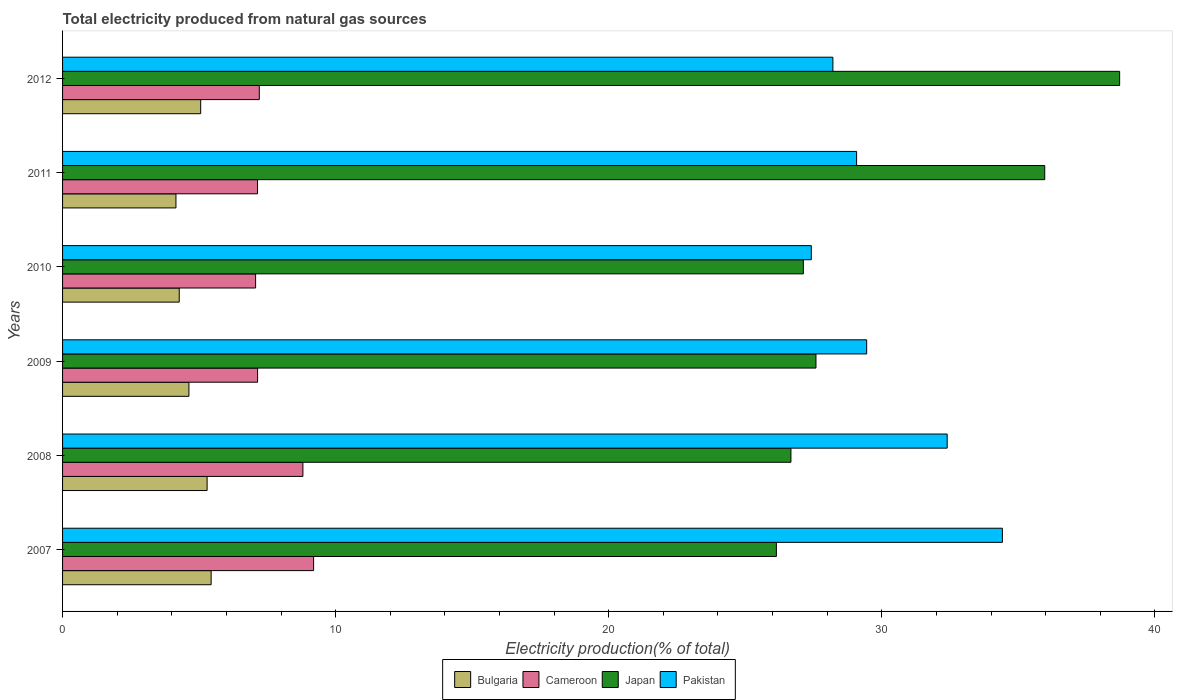How many groups of bars are there?
Your answer should be very brief. 6. Are the number of bars per tick equal to the number of legend labels?
Your response must be concise. Yes. Are the number of bars on each tick of the Y-axis equal?
Your response must be concise. Yes. How many bars are there on the 3rd tick from the top?
Give a very brief answer. 4. How many bars are there on the 4th tick from the bottom?
Your answer should be very brief. 4. What is the total electricity produced in Bulgaria in 2010?
Make the answer very short. 4.27. Across all years, what is the maximum total electricity produced in Japan?
Offer a terse response. 38.71. Across all years, what is the minimum total electricity produced in Japan?
Offer a very short reply. 26.14. What is the total total electricity produced in Japan in the graph?
Offer a very short reply. 182.21. What is the difference between the total electricity produced in Japan in 2007 and that in 2011?
Your response must be concise. -9.83. What is the difference between the total electricity produced in Japan in 2010 and the total electricity produced in Cameroon in 2007?
Your answer should be very brief. 17.93. What is the average total electricity produced in Bulgaria per year?
Ensure brevity in your answer.  4.81. In the year 2010, what is the difference between the total electricity produced in Cameroon and total electricity produced in Pakistan?
Your answer should be compact. -20.35. In how many years, is the total electricity produced in Japan greater than 14 %?
Offer a very short reply. 6. What is the ratio of the total electricity produced in Pakistan in 2011 to that in 2012?
Your response must be concise. 1.03. Is the total electricity produced in Cameroon in 2008 less than that in 2009?
Give a very brief answer. No. What is the difference between the highest and the second highest total electricity produced in Bulgaria?
Provide a succinct answer. 0.15. What is the difference between the highest and the lowest total electricity produced in Japan?
Keep it short and to the point. 12.57. What does the 3rd bar from the bottom in 2007 represents?
Give a very brief answer. Japan. Are the values on the major ticks of X-axis written in scientific E-notation?
Keep it short and to the point. No. Does the graph contain any zero values?
Give a very brief answer. No. Where does the legend appear in the graph?
Keep it short and to the point. Bottom center. How are the legend labels stacked?
Keep it short and to the point. Horizontal. What is the title of the graph?
Your response must be concise. Total electricity produced from natural gas sources. What is the label or title of the Y-axis?
Your answer should be compact. Years. What is the Electricity production(% of total) in Bulgaria in 2007?
Keep it short and to the point. 5.44. What is the Electricity production(% of total) in Cameroon in 2007?
Keep it short and to the point. 9.19. What is the Electricity production(% of total) of Japan in 2007?
Ensure brevity in your answer.  26.14. What is the Electricity production(% of total) of Pakistan in 2007?
Offer a terse response. 34.42. What is the Electricity production(% of total) in Bulgaria in 2008?
Make the answer very short. 5.29. What is the Electricity production(% of total) in Cameroon in 2008?
Keep it short and to the point. 8.8. What is the Electricity production(% of total) in Japan in 2008?
Offer a very short reply. 26.67. What is the Electricity production(% of total) in Pakistan in 2008?
Your response must be concise. 32.39. What is the Electricity production(% of total) of Bulgaria in 2009?
Your response must be concise. 4.63. What is the Electricity production(% of total) in Cameroon in 2009?
Provide a short and direct response. 7.14. What is the Electricity production(% of total) of Japan in 2009?
Keep it short and to the point. 27.59. What is the Electricity production(% of total) in Pakistan in 2009?
Offer a terse response. 29.45. What is the Electricity production(% of total) of Bulgaria in 2010?
Offer a very short reply. 4.27. What is the Electricity production(% of total) of Cameroon in 2010?
Ensure brevity in your answer.  7.07. What is the Electricity production(% of total) of Japan in 2010?
Provide a succinct answer. 27.13. What is the Electricity production(% of total) of Pakistan in 2010?
Make the answer very short. 27.42. What is the Electricity production(% of total) in Bulgaria in 2011?
Your answer should be compact. 4.15. What is the Electricity production(% of total) in Cameroon in 2011?
Provide a succinct answer. 7.14. What is the Electricity production(% of total) of Japan in 2011?
Provide a succinct answer. 35.97. What is the Electricity production(% of total) of Pakistan in 2011?
Make the answer very short. 29.08. What is the Electricity production(% of total) of Bulgaria in 2012?
Your answer should be very brief. 5.06. What is the Electricity production(% of total) in Cameroon in 2012?
Provide a succinct answer. 7.2. What is the Electricity production(% of total) in Japan in 2012?
Your answer should be very brief. 38.71. What is the Electricity production(% of total) in Pakistan in 2012?
Your answer should be very brief. 28.21. Across all years, what is the maximum Electricity production(% of total) in Bulgaria?
Provide a succinct answer. 5.44. Across all years, what is the maximum Electricity production(% of total) of Cameroon?
Provide a short and direct response. 9.19. Across all years, what is the maximum Electricity production(% of total) of Japan?
Offer a very short reply. 38.71. Across all years, what is the maximum Electricity production(% of total) of Pakistan?
Offer a terse response. 34.42. Across all years, what is the minimum Electricity production(% of total) of Bulgaria?
Ensure brevity in your answer.  4.15. Across all years, what is the minimum Electricity production(% of total) of Cameroon?
Give a very brief answer. 7.07. Across all years, what is the minimum Electricity production(% of total) of Japan?
Your answer should be compact. 26.14. Across all years, what is the minimum Electricity production(% of total) of Pakistan?
Provide a short and direct response. 27.42. What is the total Electricity production(% of total) in Bulgaria in the graph?
Give a very brief answer. 28.84. What is the total Electricity production(% of total) of Cameroon in the graph?
Provide a short and direct response. 46.55. What is the total Electricity production(% of total) in Japan in the graph?
Keep it short and to the point. 182.21. What is the total Electricity production(% of total) in Pakistan in the graph?
Provide a short and direct response. 180.96. What is the difference between the Electricity production(% of total) in Bulgaria in 2007 and that in 2008?
Your answer should be very brief. 0.15. What is the difference between the Electricity production(% of total) of Cameroon in 2007 and that in 2008?
Your answer should be very brief. 0.39. What is the difference between the Electricity production(% of total) of Japan in 2007 and that in 2008?
Offer a terse response. -0.53. What is the difference between the Electricity production(% of total) in Pakistan in 2007 and that in 2008?
Offer a very short reply. 2.02. What is the difference between the Electricity production(% of total) of Bulgaria in 2007 and that in 2009?
Your answer should be compact. 0.81. What is the difference between the Electricity production(% of total) in Cameroon in 2007 and that in 2009?
Make the answer very short. 2.05. What is the difference between the Electricity production(% of total) of Japan in 2007 and that in 2009?
Provide a short and direct response. -1.45. What is the difference between the Electricity production(% of total) in Pakistan in 2007 and that in 2009?
Keep it short and to the point. 4.97. What is the difference between the Electricity production(% of total) of Bulgaria in 2007 and that in 2010?
Give a very brief answer. 1.17. What is the difference between the Electricity production(% of total) in Cameroon in 2007 and that in 2010?
Your answer should be very brief. 2.12. What is the difference between the Electricity production(% of total) of Japan in 2007 and that in 2010?
Ensure brevity in your answer.  -0.99. What is the difference between the Electricity production(% of total) of Pakistan in 2007 and that in 2010?
Ensure brevity in your answer.  7. What is the difference between the Electricity production(% of total) in Bulgaria in 2007 and that in 2011?
Your response must be concise. 1.29. What is the difference between the Electricity production(% of total) in Cameroon in 2007 and that in 2011?
Provide a short and direct response. 2.05. What is the difference between the Electricity production(% of total) in Japan in 2007 and that in 2011?
Offer a very short reply. -9.83. What is the difference between the Electricity production(% of total) in Pakistan in 2007 and that in 2011?
Ensure brevity in your answer.  5.34. What is the difference between the Electricity production(% of total) of Bulgaria in 2007 and that in 2012?
Your answer should be compact. 0.38. What is the difference between the Electricity production(% of total) in Cameroon in 2007 and that in 2012?
Give a very brief answer. 1.99. What is the difference between the Electricity production(% of total) in Japan in 2007 and that in 2012?
Offer a very short reply. -12.57. What is the difference between the Electricity production(% of total) in Pakistan in 2007 and that in 2012?
Make the answer very short. 6.21. What is the difference between the Electricity production(% of total) in Bulgaria in 2008 and that in 2009?
Make the answer very short. 0.67. What is the difference between the Electricity production(% of total) in Cameroon in 2008 and that in 2009?
Offer a very short reply. 1.66. What is the difference between the Electricity production(% of total) in Japan in 2008 and that in 2009?
Your answer should be compact. -0.92. What is the difference between the Electricity production(% of total) in Pakistan in 2008 and that in 2009?
Ensure brevity in your answer.  2.95. What is the difference between the Electricity production(% of total) of Cameroon in 2008 and that in 2010?
Offer a very short reply. 1.73. What is the difference between the Electricity production(% of total) of Japan in 2008 and that in 2010?
Provide a succinct answer. -0.45. What is the difference between the Electricity production(% of total) of Pakistan in 2008 and that in 2010?
Offer a very short reply. 4.98. What is the difference between the Electricity production(% of total) of Bulgaria in 2008 and that in 2011?
Make the answer very short. 1.14. What is the difference between the Electricity production(% of total) in Cameroon in 2008 and that in 2011?
Provide a succinct answer. 1.66. What is the difference between the Electricity production(% of total) in Japan in 2008 and that in 2011?
Give a very brief answer. -9.29. What is the difference between the Electricity production(% of total) in Pakistan in 2008 and that in 2011?
Provide a succinct answer. 3.32. What is the difference between the Electricity production(% of total) of Bulgaria in 2008 and that in 2012?
Your response must be concise. 0.24. What is the difference between the Electricity production(% of total) in Cameroon in 2008 and that in 2012?
Give a very brief answer. 1.6. What is the difference between the Electricity production(% of total) of Japan in 2008 and that in 2012?
Your response must be concise. -12.04. What is the difference between the Electricity production(% of total) of Pakistan in 2008 and that in 2012?
Offer a very short reply. 4.18. What is the difference between the Electricity production(% of total) of Bulgaria in 2009 and that in 2010?
Ensure brevity in your answer.  0.35. What is the difference between the Electricity production(% of total) in Cameroon in 2009 and that in 2010?
Make the answer very short. 0.07. What is the difference between the Electricity production(% of total) in Japan in 2009 and that in 2010?
Keep it short and to the point. 0.46. What is the difference between the Electricity production(% of total) in Pakistan in 2009 and that in 2010?
Offer a very short reply. 2.03. What is the difference between the Electricity production(% of total) of Bulgaria in 2009 and that in 2011?
Offer a very short reply. 0.47. What is the difference between the Electricity production(% of total) of Cameroon in 2009 and that in 2011?
Provide a succinct answer. 0. What is the difference between the Electricity production(% of total) of Japan in 2009 and that in 2011?
Your answer should be compact. -8.38. What is the difference between the Electricity production(% of total) of Pakistan in 2009 and that in 2011?
Your answer should be compact. 0.37. What is the difference between the Electricity production(% of total) in Bulgaria in 2009 and that in 2012?
Provide a succinct answer. -0.43. What is the difference between the Electricity production(% of total) of Cameroon in 2009 and that in 2012?
Your response must be concise. -0.06. What is the difference between the Electricity production(% of total) in Japan in 2009 and that in 2012?
Ensure brevity in your answer.  -11.12. What is the difference between the Electricity production(% of total) of Pakistan in 2009 and that in 2012?
Your answer should be compact. 1.24. What is the difference between the Electricity production(% of total) in Bulgaria in 2010 and that in 2011?
Offer a terse response. 0.12. What is the difference between the Electricity production(% of total) in Cameroon in 2010 and that in 2011?
Provide a short and direct response. -0.07. What is the difference between the Electricity production(% of total) of Japan in 2010 and that in 2011?
Your answer should be very brief. -8.84. What is the difference between the Electricity production(% of total) in Pakistan in 2010 and that in 2011?
Offer a very short reply. -1.66. What is the difference between the Electricity production(% of total) in Bulgaria in 2010 and that in 2012?
Keep it short and to the point. -0.79. What is the difference between the Electricity production(% of total) of Cameroon in 2010 and that in 2012?
Provide a short and direct response. -0.14. What is the difference between the Electricity production(% of total) of Japan in 2010 and that in 2012?
Make the answer very short. -11.58. What is the difference between the Electricity production(% of total) of Pakistan in 2010 and that in 2012?
Make the answer very short. -0.79. What is the difference between the Electricity production(% of total) in Bulgaria in 2011 and that in 2012?
Your answer should be very brief. -0.91. What is the difference between the Electricity production(% of total) of Cameroon in 2011 and that in 2012?
Ensure brevity in your answer.  -0.06. What is the difference between the Electricity production(% of total) of Japan in 2011 and that in 2012?
Your response must be concise. -2.74. What is the difference between the Electricity production(% of total) of Pakistan in 2011 and that in 2012?
Your answer should be very brief. 0.87. What is the difference between the Electricity production(% of total) in Bulgaria in 2007 and the Electricity production(% of total) in Cameroon in 2008?
Offer a terse response. -3.36. What is the difference between the Electricity production(% of total) of Bulgaria in 2007 and the Electricity production(% of total) of Japan in 2008?
Offer a terse response. -21.23. What is the difference between the Electricity production(% of total) in Bulgaria in 2007 and the Electricity production(% of total) in Pakistan in 2008?
Your response must be concise. -26.95. What is the difference between the Electricity production(% of total) in Cameroon in 2007 and the Electricity production(% of total) in Japan in 2008?
Give a very brief answer. -17.48. What is the difference between the Electricity production(% of total) of Cameroon in 2007 and the Electricity production(% of total) of Pakistan in 2008?
Give a very brief answer. -23.2. What is the difference between the Electricity production(% of total) in Japan in 2007 and the Electricity production(% of total) in Pakistan in 2008?
Make the answer very short. -6.25. What is the difference between the Electricity production(% of total) of Bulgaria in 2007 and the Electricity production(% of total) of Cameroon in 2009?
Ensure brevity in your answer.  -1.7. What is the difference between the Electricity production(% of total) in Bulgaria in 2007 and the Electricity production(% of total) in Japan in 2009?
Give a very brief answer. -22.15. What is the difference between the Electricity production(% of total) in Bulgaria in 2007 and the Electricity production(% of total) in Pakistan in 2009?
Provide a short and direct response. -24.01. What is the difference between the Electricity production(% of total) in Cameroon in 2007 and the Electricity production(% of total) in Japan in 2009?
Offer a very short reply. -18.4. What is the difference between the Electricity production(% of total) of Cameroon in 2007 and the Electricity production(% of total) of Pakistan in 2009?
Your answer should be very brief. -20.25. What is the difference between the Electricity production(% of total) in Japan in 2007 and the Electricity production(% of total) in Pakistan in 2009?
Provide a short and direct response. -3.31. What is the difference between the Electricity production(% of total) of Bulgaria in 2007 and the Electricity production(% of total) of Cameroon in 2010?
Your answer should be compact. -1.63. What is the difference between the Electricity production(% of total) of Bulgaria in 2007 and the Electricity production(% of total) of Japan in 2010?
Keep it short and to the point. -21.69. What is the difference between the Electricity production(% of total) of Bulgaria in 2007 and the Electricity production(% of total) of Pakistan in 2010?
Make the answer very short. -21.98. What is the difference between the Electricity production(% of total) in Cameroon in 2007 and the Electricity production(% of total) in Japan in 2010?
Your answer should be very brief. -17.93. What is the difference between the Electricity production(% of total) in Cameroon in 2007 and the Electricity production(% of total) in Pakistan in 2010?
Your answer should be compact. -18.23. What is the difference between the Electricity production(% of total) in Japan in 2007 and the Electricity production(% of total) in Pakistan in 2010?
Provide a short and direct response. -1.28. What is the difference between the Electricity production(% of total) of Bulgaria in 2007 and the Electricity production(% of total) of Cameroon in 2011?
Provide a succinct answer. -1.7. What is the difference between the Electricity production(% of total) in Bulgaria in 2007 and the Electricity production(% of total) in Japan in 2011?
Offer a terse response. -30.53. What is the difference between the Electricity production(% of total) in Bulgaria in 2007 and the Electricity production(% of total) in Pakistan in 2011?
Ensure brevity in your answer.  -23.64. What is the difference between the Electricity production(% of total) in Cameroon in 2007 and the Electricity production(% of total) in Japan in 2011?
Your response must be concise. -26.77. What is the difference between the Electricity production(% of total) in Cameroon in 2007 and the Electricity production(% of total) in Pakistan in 2011?
Keep it short and to the point. -19.88. What is the difference between the Electricity production(% of total) in Japan in 2007 and the Electricity production(% of total) in Pakistan in 2011?
Your answer should be compact. -2.94. What is the difference between the Electricity production(% of total) of Bulgaria in 2007 and the Electricity production(% of total) of Cameroon in 2012?
Your answer should be compact. -1.76. What is the difference between the Electricity production(% of total) in Bulgaria in 2007 and the Electricity production(% of total) in Japan in 2012?
Offer a terse response. -33.27. What is the difference between the Electricity production(% of total) of Bulgaria in 2007 and the Electricity production(% of total) of Pakistan in 2012?
Provide a short and direct response. -22.77. What is the difference between the Electricity production(% of total) of Cameroon in 2007 and the Electricity production(% of total) of Japan in 2012?
Ensure brevity in your answer.  -29.52. What is the difference between the Electricity production(% of total) in Cameroon in 2007 and the Electricity production(% of total) in Pakistan in 2012?
Offer a very short reply. -19.02. What is the difference between the Electricity production(% of total) in Japan in 2007 and the Electricity production(% of total) in Pakistan in 2012?
Ensure brevity in your answer.  -2.07. What is the difference between the Electricity production(% of total) in Bulgaria in 2008 and the Electricity production(% of total) in Cameroon in 2009?
Offer a terse response. -1.85. What is the difference between the Electricity production(% of total) of Bulgaria in 2008 and the Electricity production(% of total) of Japan in 2009?
Give a very brief answer. -22.3. What is the difference between the Electricity production(% of total) of Bulgaria in 2008 and the Electricity production(% of total) of Pakistan in 2009?
Your answer should be compact. -24.15. What is the difference between the Electricity production(% of total) of Cameroon in 2008 and the Electricity production(% of total) of Japan in 2009?
Offer a terse response. -18.79. What is the difference between the Electricity production(% of total) in Cameroon in 2008 and the Electricity production(% of total) in Pakistan in 2009?
Your answer should be compact. -20.64. What is the difference between the Electricity production(% of total) in Japan in 2008 and the Electricity production(% of total) in Pakistan in 2009?
Provide a succinct answer. -2.77. What is the difference between the Electricity production(% of total) in Bulgaria in 2008 and the Electricity production(% of total) in Cameroon in 2010?
Provide a short and direct response. -1.78. What is the difference between the Electricity production(% of total) of Bulgaria in 2008 and the Electricity production(% of total) of Japan in 2010?
Ensure brevity in your answer.  -21.83. What is the difference between the Electricity production(% of total) of Bulgaria in 2008 and the Electricity production(% of total) of Pakistan in 2010?
Keep it short and to the point. -22.13. What is the difference between the Electricity production(% of total) of Cameroon in 2008 and the Electricity production(% of total) of Japan in 2010?
Make the answer very short. -18.33. What is the difference between the Electricity production(% of total) of Cameroon in 2008 and the Electricity production(% of total) of Pakistan in 2010?
Ensure brevity in your answer.  -18.62. What is the difference between the Electricity production(% of total) of Japan in 2008 and the Electricity production(% of total) of Pakistan in 2010?
Your answer should be very brief. -0.75. What is the difference between the Electricity production(% of total) in Bulgaria in 2008 and the Electricity production(% of total) in Cameroon in 2011?
Your response must be concise. -1.85. What is the difference between the Electricity production(% of total) of Bulgaria in 2008 and the Electricity production(% of total) of Japan in 2011?
Keep it short and to the point. -30.67. What is the difference between the Electricity production(% of total) of Bulgaria in 2008 and the Electricity production(% of total) of Pakistan in 2011?
Your answer should be compact. -23.78. What is the difference between the Electricity production(% of total) of Cameroon in 2008 and the Electricity production(% of total) of Japan in 2011?
Make the answer very short. -27.17. What is the difference between the Electricity production(% of total) of Cameroon in 2008 and the Electricity production(% of total) of Pakistan in 2011?
Provide a short and direct response. -20.28. What is the difference between the Electricity production(% of total) in Japan in 2008 and the Electricity production(% of total) in Pakistan in 2011?
Offer a terse response. -2.4. What is the difference between the Electricity production(% of total) of Bulgaria in 2008 and the Electricity production(% of total) of Cameroon in 2012?
Your response must be concise. -1.91. What is the difference between the Electricity production(% of total) in Bulgaria in 2008 and the Electricity production(% of total) in Japan in 2012?
Provide a short and direct response. -33.42. What is the difference between the Electricity production(% of total) in Bulgaria in 2008 and the Electricity production(% of total) in Pakistan in 2012?
Offer a terse response. -22.92. What is the difference between the Electricity production(% of total) in Cameroon in 2008 and the Electricity production(% of total) in Japan in 2012?
Your response must be concise. -29.91. What is the difference between the Electricity production(% of total) of Cameroon in 2008 and the Electricity production(% of total) of Pakistan in 2012?
Offer a very short reply. -19.41. What is the difference between the Electricity production(% of total) in Japan in 2008 and the Electricity production(% of total) in Pakistan in 2012?
Provide a short and direct response. -1.54. What is the difference between the Electricity production(% of total) in Bulgaria in 2009 and the Electricity production(% of total) in Cameroon in 2010?
Keep it short and to the point. -2.44. What is the difference between the Electricity production(% of total) in Bulgaria in 2009 and the Electricity production(% of total) in Japan in 2010?
Give a very brief answer. -22.5. What is the difference between the Electricity production(% of total) of Bulgaria in 2009 and the Electricity production(% of total) of Pakistan in 2010?
Your response must be concise. -22.79. What is the difference between the Electricity production(% of total) in Cameroon in 2009 and the Electricity production(% of total) in Japan in 2010?
Make the answer very short. -19.99. What is the difference between the Electricity production(% of total) of Cameroon in 2009 and the Electricity production(% of total) of Pakistan in 2010?
Make the answer very short. -20.28. What is the difference between the Electricity production(% of total) in Japan in 2009 and the Electricity production(% of total) in Pakistan in 2010?
Your answer should be very brief. 0.17. What is the difference between the Electricity production(% of total) in Bulgaria in 2009 and the Electricity production(% of total) in Cameroon in 2011?
Provide a succinct answer. -2.51. What is the difference between the Electricity production(% of total) in Bulgaria in 2009 and the Electricity production(% of total) in Japan in 2011?
Ensure brevity in your answer.  -31.34. What is the difference between the Electricity production(% of total) of Bulgaria in 2009 and the Electricity production(% of total) of Pakistan in 2011?
Provide a succinct answer. -24.45. What is the difference between the Electricity production(% of total) in Cameroon in 2009 and the Electricity production(% of total) in Japan in 2011?
Your answer should be compact. -28.83. What is the difference between the Electricity production(% of total) of Cameroon in 2009 and the Electricity production(% of total) of Pakistan in 2011?
Your answer should be compact. -21.94. What is the difference between the Electricity production(% of total) in Japan in 2009 and the Electricity production(% of total) in Pakistan in 2011?
Your response must be concise. -1.49. What is the difference between the Electricity production(% of total) in Bulgaria in 2009 and the Electricity production(% of total) in Cameroon in 2012?
Make the answer very short. -2.58. What is the difference between the Electricity production(% of total) of Bulgaria in 2009 and the Electricity production(% of total) of Japan in 2012?
Ensure brevity in your answer.  -34.08. What is the difference between the Electricity production(% of total) in Bulgaria in 2009 and the Electricity production(% of total) in Pakistan in 2012?
Give a very brief answer. -23.58. What is the difference between the Electricity production(% of total) of Cameroon in 2009 and the Electricity production(% of total) of Japan in 2012?
Make the answer very short. -31.57. What is the difference between the Electricity production(% of total) of Cameroon in 2009 and the Electricity production(% of total) of Pakistan in 2012?
Give a very brief answer. -21.07. What is the difference between the Electricity production(% of total) of Japan in 2009 and the Electricity production(% of total) of Pakistan in 2012?
Give a very brief answer. -0.62. What is the difference between the Electricity production(% of total) of Bulgaria in 2010 and the Electricity production(% of total) of Cameroon in 2011?
Provide a succinct answer. -2.87. What is the difference between the Electricity production(% of total) in Bulgaria in 2010 and the Electricity production(% of total) in Japan in 2011?
Offer a very short reply. -31.69. What is the difference between the Electricity production(% of total) in Bulgaria in 2010 and the Electricity production(% of total) in Pakistan in 2011?
Give a very brief answer. -24.81. What is the difference between the Electricity production(% of total) in Cameroon in 2010 and the Electricity production(% of total) in Japan in 2011?
Your response must be concise. -28.9. What is the difference between the Electricity production(% of total) of Cameroon in 2010 and the Electricity production(% of total) of Pakistan in 2011?
Your answer should be very brief. -22.01. What is the difference between the Electricity production(% of total) in Japan in 2010 and the Electricity production(% of total) in Pakistan in 2011?
Keep it short and to the point. -1.95. What is the difference between the Electricity production(% of total) of Bulgaria in 2010 and the Electricity production(% of total) of Cameroon in 2012?
Provide a succinct answer. -2.93. What is the difference between the Electricity production(% of total) in Bulgaria in 2010 and the Electricity production(% of total) in Japan in 2012?
Make the answer very short. -34.44. What is the difference between the Electricity production(% of total) of Bulgaria in 2010 and the Electricity production(% of total) of Pakistan in 2012?
Ensure brevity in your answer.  -23.94. What is the difference between the Electricity production(% of total) of Cameroon in 2010 and the Electricity production(% of total) of Japan in 2012?
Provide a succinct answer. -31.64. What is the difference between the Electricity production(% of total) of Cameroon in 2010 and the Electricity production(% of total) of Pakistan in 2012?
Provide a succinct answer. -21.14. What is the difference between the Electricity production(% of total) in Japan in 2010 and the Electricity production(% of total) in Pakistan in 2012?
Provide a short and direct response. -1.08. What is the difference between the Electricity production(% of total) in Bulgaria in 2011 and the Electricity production(% of total) in Cameroon in 2012?
Your answer should be very brief. -3.05. What is the difference between the Electricity production(% of total) of Bulgaria in 2011 and the Electricity production(% of total) of Japan in 2012?
Provide a succinct answer. -34.56. What is the difference between the Electricity production(% of total) of Bulgaria in 2011 and the Electricity production(% of total) of Pakistan in 2012?
Offer a terse response. -24.06. What is the difference between the Electricity production(% of total) of Cameroon in 2011 and the Electricity production(% of total) of Japan in 2012?
Ensure brevity in your answer.  -31.57. What is the difference between the Electricity production(% of total) in Cameroon in 2011 and the Electricity production(% of total) in Pakistan in 2012?
Provide a succinct answer. -21.07. What is the difference between the Electricity production(% of total) in Japan in 2011 and the Electricity production(% of total) in Pakistan in 2012?
Give a very brief answer. 7.76. What is the average Electricity production(% of total) of Bulgaria per year?
Provide a succinct answer. 4.81. What is the average Electricity production(% of total) of Cameroon per year?
Offer a terse response. 7.76. What is the average Electricity production(% of total) in Japan per year?
Offer a very short reply. 30.37. What is the average Electricity production(% of total) of Pakistan per year?
Offer a very short reply. 30.16. In the year 2007, what is the difference between the Electricity production(% of total) in Bulgaria and Electricity production(% of total) in Cameroon?
Keep it short and to the point. -3.75. In the year 2007, what is the difference between the Electricity production(% of total) of Bulgaria and Electricity production(% of total) of Japan?
Give a very brief answer. -20.7. In the year 2007, what is the difference between the Electricity production(% of total) of Bulgaria and Electricity production(% of total) of Pakistan?
Give a very brief answer. -28.98. In the year 2007, what is the difference between the Electricity production(% of total) of Cameroon and Electricity production(% of total) of Japan?
Provide a short and direct response. -16.95. In the year 2007, what is the difference between the Electricity production(% of total) of Cameroon and Electricity production(% of total) of Pakistan?
Your answer should be compact. -25.22. In the year 2007, what is the difference between the Electricity production(% of total) of Japan and Electricity production(% of total) of Pakistan?
Ensure brevity in your answer.  -8.28. In the year 2008, what is the difference between the Electricity production(% of total) in Bulgaria and Electricity production(% of total) in Cameroon?
Offer a very short reply. -3.51. In the year 2008, what is the difference between the Electricity production(% of total) of Bulgaria and Electricity production(% of total) of Japan?
Provide a short and direct response. -21.38. In the year 2008, what is the difference between the Electricity production(% of total) in Bulgaria and Electricity production(% of total) in Pakistan?
Offer a very short reply. -27.1. In the year 2008, what is the difference between the Electricity production(% of total) in Cameroon and Electricity production(% of total) in Japan?
Your answer should be compact. -17.87. In the year 2008, what is the difference between the Electricity production(% of total) of Cameroon and Electricity production(% of total) of Pakistan?
Your answer should be compact. -23.59. In the year 2008, what is the difference between the Electricity production(% of total) in Japan and Electricity production(% of total) in Pakistan?
Ensure brevity in your answer.  -5.72. In the year 2009, what is the difference between the Electricity production(% of total) in Bulgaria and Electricity production(% of total) in Cameroon?
Provide a short and direct response. -2.51. In the year 2009, what is the difference between the Electricity production(% of total) in Bulgaria and Electricity production(% of total) in Japan?
Your response must be concise. -22.96. In the year 2009, what is the difference between the Electricity production(% of total) of Bulgaria and Electricity production(% of total) of Pakistan?
Provide a short and direct response. -24.82. In the year 2009, what is the difference between the Electricity production(% of total) of Cameroon and Electricity production(% of total) of Japan?
Make the answer very short. -20.45. In the year 2009, what is the difference between the Electricity production(% of total) of Cameroon and Electricity production(% of total) of Pakistan?
Ensure brevity in your answer.  -22.3. In the year 2009, what is the difference between the Electricity production(% of total) in Japan and Electricity production(% of total) in Pakistan?
Your response must be concise. -1.86. In the year 2010, what is the difference between the Electricity production(% of total) of Bulgaria and Electricity production(% of total) of Cameroon?
Provide a short and direct response. -2.8. In the year 2010, what is the difference between the Electricity production(% of total) of Bulgaria and Electricity production(% of total) of Japan?
Your answer should be very brief. -22.86. In the year 2010, what is the difference between the Electricity production(% of total) of Bulgaria and Electricity production(% of total) of Pakistan?
Make the answer very short. -23.15. In the year 2010, what is the difference between the Electricity production(% of total) of Cameroon and Electricity production(% of total) of Japan?
Offer a terse response. -20.06. In the year 2010, what is the difference between the Electricity production(% of total) in Cameroon and Electricity production(% of total) in Pakistan?
Your answer should be compact. -20.35. In the year 2010, what is the difference between the Electricity production(% of total) of Japan and Electricity production(% of total) of Pakistan?
Your answer should be compact. -0.29. In the year 2011, what is the difference between the Electricity production(% of total) of Bulgaria and Electricity production(% of total) of Cameroon?
Ensure brevity in your answer.  -2.99. In the year 2011, what is the difference between the Electricity production(% of total) of Bulgaria and Electricity production(% of total) of Japan?
Offer a terse response. -31.82. In the year 2011, what is the difference between the Electricity production(% of total) of Bulgaria and Electricity production(% of total) of Pakistan?
Offer a terse response. -24.93. In the year 2011, what is the difference between the Electricity production(% of total) of Cameroon and Electricity production(% of total) of Japan?
Keep it short and to the point. -28.83. In the year 2011, what is the difference between the Electricity production(% of total) in Cameroon and Electricity production(% of total) in Pakistan?
Your answer should be very brief. -21.94. In the year 2011, what is the difference between the Electricity production(% of total) of Japan and Electricity production(% of total) of Pakistan?
Keep it short and to the point. 6.89. In the year 2012, what is the difference between the Electricity production(% of total) in Bulgaria and Electricity production(% of total) in Cameroon?
Make the answer very short. -2.15. In the year 2012, what is the difference between the Electricity production(% of total) in Bulgaria and Electricity production(% of total) in Japan?
Give a very brief answer. -33.65. In the year 2012, what is the difference between the Electricity production(% of total) of Bulgaria and Electricity production(% of total) of Pakistan?
Keep it short and to the point. -23.15. In the year 2012, what is the difference between the Electricity production(% of total) in Cameroon and Electricity production(% of total) in Japan?
Your response must be concise. -31.51. In the year 2012, what is the difference between the Electricity production(% of total) in Cameroon and Electricity production(% of total) in Pakistan?
Your response must be concise. -21. In the year 2012, what is the difference between the Electricity production(% of total) of Japan and Electricity production(% of total) of Pakistan?
Offer a terse response. 10.5. What is the ratio of the Electricity production(% of total) in Bulgaria in 2007 to that in 2008?
Your answer should be compact. 1.03. What is the ratio of the Electricity production(% of total) of Cameroon in 2007 to that in 2008?
Offer a terse response. 1.04. What is the ratio of the Electricity production(% of total) in Japan in 2007 to that in 2008?
Your answer should be very brief. 0.98. What is the ratio of the Electricity production(% of total) in Pakistan in 2007 to that in 2008?
Provide a short and direct response. 1.06. What is the ratio of the Electricity production(% of total) of Bulgaria in 2007 to that in 2009?
Make the answer very short. 1.18. What is the ratio of the Electricity production(% of total) in Cameroon in 2007 to that in 2009?
Keep it short and to the point. 1.29. What is the ratio of the Electricity production(% of total) of Japan in 2007 to that in 2009?
Your answer should be compact. 0.95. What is the ratio of the Electricity production(% of total) of Pakistan in 2007 to that in 2009?
Your answer should be very brief. 1.17. What is the ratio of the Electricity production(% of total) in Bulgaria in 2007 to that in 2010?
Keep it short and to the point. 1.27. What is the ratio of the Electricity production(% of total) of Cameroon in 2007 to that in 2010?
Offer a very short reply. 1.3. What is the ratio of the Electricity production(% of total) in Japan in 2007 to that in 2010?
Provide a short and direct response. 0.96. What is the ratio of the Electricity production(% of total) in Pakistan in 2007 to that in 2010?
Make the answer very short. 1.26. What is the ratio of the Electricity production(% of total) of Bulgaria in 2007 to that in 2011?
Keep it short and to the point. 1.31. What is the ratio of the Electricity production(% of total) of Cameroon in 2007 to that in 2011?
Give a very brief answer. 1.29. What is the ratio of the Electricity production(% of total) of Japan in 2007 to that in 2011?
Keep it short and to the point. 0.73. What is the ratio of the Electricity production(% of total) of Pakistan in 2007 to that in 2011?
Your response must be concise. 1.18. What is the ratio of the Electricity production(% of total) in Bulgaria in 2007 to that in 2012?
Ensure brevity in your answer.  1.08. What is the ratio of the Electricity production(% of total) of Cameroon in 2007 to that in 2012?
Give a very brief answer. 1.28. What is the ratio of the Electricity production(% of total) of Japan in 2007 to that in 2012?
Your answer should be compact. 0.68. What is the ratio of the Electricity production(% of total) of Pakistan in 2007 to that in 2012?
Your answer should be very brief. 1.22. What is the ratio of the Electricity production(% of total) in Bulgaria in 2008 to that in 2009?
Your answer should be compact. 1.14. What is the ratio of the Electricity production(% of total) in Cameroon in 2008 to that in 2009?
Your answer should be compact. 1.23. What is the ratio of the Electricity production(% of total) in Japan in 2008 to that in 2009?
Your response must be concise. 0.97. What is the ratio of the Electricity production(% of total) in Pakistan in 2008 to that in 2009?
Your answer should be very brief. 1.1. What is the ratio of the Electricity production(% of total) of Bulgaria in 2008 to that in 2010?
Your answer should be compact. 1.24. What is the ratio of the Electricity production(% of total) in Cameroon in 2008 to that in 2010?
Give a very brief answer. 1.25. What is the ratio of the Electricity production(% of total) of Japan in 2008 to that in 2010?
Give a very brief answer. 0.98. What is the ratio of the Electricity production(% of total) of Pakistan in 2008 to that in 2010?
Provide a succinct answer. 1.18. What is the ratio of the Electricity production(% of total) in Bulgaria in 2008 to that in 2011?
Provide a succinct answer. 1.27. What is the ratio of the Electricity production(% of total) in Cameroon in 2008 to that in 2011?
Offer a very short reply. 1.23. What is the ratio of the Electricity production(% of total) in Japan in 2008 to that in 2011?
Your response must be concise. 0.74. What is the ratio of the Electricity production(% of total) in Pakistan in 2008 to that in 2011?
Your response must be concise. 1.11. What is the ratio of the Electricity production(% of total) of Bulgaria in 2008 to that in 2012?
Make the answer very short. 1.05. What is the ratio of the Electricity production(% of total) in Cameroon in 2008 to that in 2012?
Make the answer very short. 1.22. What is the ratio of the Electricity production(% of total) of Japan in 2008 to that in 2012?
Your answer should be very brief. 0.69. What is the ratio of the Electricity production(% of total) of Pakistan in 2008 to that in 2012?
Provide a short and direct response. 1.15. What is the ratio of the Electricity production(% of total) of Bulgaria in 2009 to that in 2010?
Your response must be concise. 1.08. What is the ratio of the Electricity production(% of total) in Cameroon in 2009 to that in 2010?
Keep it short and to the point. 1.01. What is the ratio of the Electricity production(% of total) in Japan in 2009 to that in 2010?
Offer a very short reply. 1.02. What is the ratio of the Electricity production(% of total) in Pakistan in 2009 to that in 2010?
Provide a succinct answer. 1.07. What is the ratio of the Electricity production(% of total) in Bulgaria in 2009 to that in 2011?
Provide a short and direct response. 1.11. What is the ratio of the Electricity production(% of total) of Cameroon in 2009 to that in 2011?
Make the answer very short. 1. What is the ratio of the Electricity production(% of total) of Japan in 2009 to that in 2011?
Keep it short and to the point. 0.77. What is the ratio of the Electricity production(% of total) in Pakistan in 2009 to that in 2011?
Provide a succinct answer. 1.01. What is the ratio of the Electricity production(% of total) of Bulgaria in 2009 to that in 2012?
Offer a terse response. 0.91. What is the ratio of the Electricity production(% of total) of Cameroon in 2009 to that in 2012?
Offer a very short reply. 0.99. What is the ratio of the Electricity production(% of total) in Japan in 2009 to that in 2012?
Your answer should be very brief. 0.71. What is the ratio of the Electricity production(% of total) in Pakistan in 2009 to that in 2012?
Offer a very short reply. 1.04. What is the ratio of the Electricity production(% of total) of Bulgaria in 2010 to that in 2011?
Provide a succinct answer. 1.03. What is the ratio of the Electricity production(% of total) of Cameroon in 2010 to that in 2011?
Offer a terse response. 0.99. What is the ratio of the Electricity production(% of total) in Japan in 2010 to that in 2011?
Provide a succinct answer. 0.75. What is the ratio of the Electricity production(% of total) in Pakistan in 2010 to that in 2011?
Give a very brief answer. 0.94. What is the ratio of the Electricity production(% of total) in Bulgaria in 2010 to that in 2012?
Offer a very short reply. 0.84. What is the ratio of the Electricity production(% of total) in Cameroon in 2010 to that in 2012?
Offer a very short reply. 0.98. What is the ratio of the Electricity production(% of total) in Japan in 2010 to that in 2012?
Provide a succinct answer. 0.7. What is the ratio of the Electricity production(% of total) of Pakistan in 2010 to that in 2012?
Make the answer very short. 0.97. What is the ratio of the Electricity production(% of total) in Bulgaria in 2011 to that in 2012?
Provide a short and direct response. 0.82. What is the ratio of the Electricity production(% of total) of Japan in 2011 to that in 2012?
Offer a very short reply. 0.93. What is the ratio of the Electricity production(% of total) in Pakistan in 2011 to that in 2012?
Offer a very short reply. 1.03. What is the difference between the highest and the second highest Electricity production(% of total) in Bulgaria?
Your response must be concise. 0.15. What is the difference between the highest and the second highest Electricity production(% of total) in Cameroon?
Provide a short and direct response. 0.39. What is the difference between the highest and the second highest Electricity production(% of total) of Japan?
Your response must be concise. 2.74. What is the difference between the highest and the second highest Electricity production(% of total) of Pakistan?
Your answer should be very brief. 2.02. What is the difference between the highest and the lowest Electricity production(% of total) of Bulgaria?
Ensure brevity in your answer.  1.29. What is the difference between the highest and the lowest Electricity production(% of total) in Cameroon?
Ensure brevity in your answer.  2.12. What is the difference between the highest and the lowest Electricity production(% of total) in Japan?
Make the answer very short. 12.57. What is the difference between the highest and the lowest Electricity production(% of total) in Pakistan?
Your answer should be very brief. 7. 